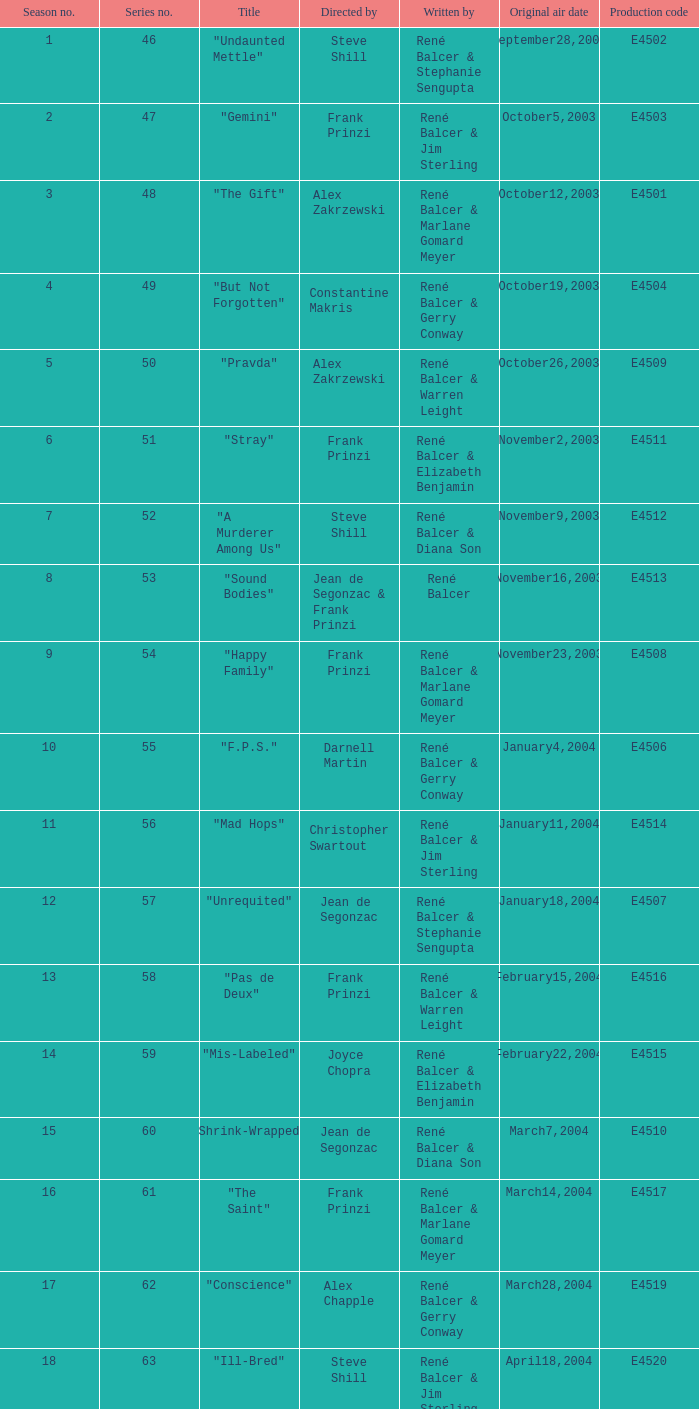Who authored the episode with e4515 as the production code? René Balcer & Elizabeth Benjamin. 